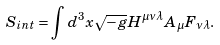<formula> <loc_0><loc_0><loc_500><loc_500>S _ { i n t } = \int d ^ { 3 } x \sqrt { - g } H ^ { \mu \nu \lambda } A _ { \mu } F _ { \nu \lambda } .</formula> 